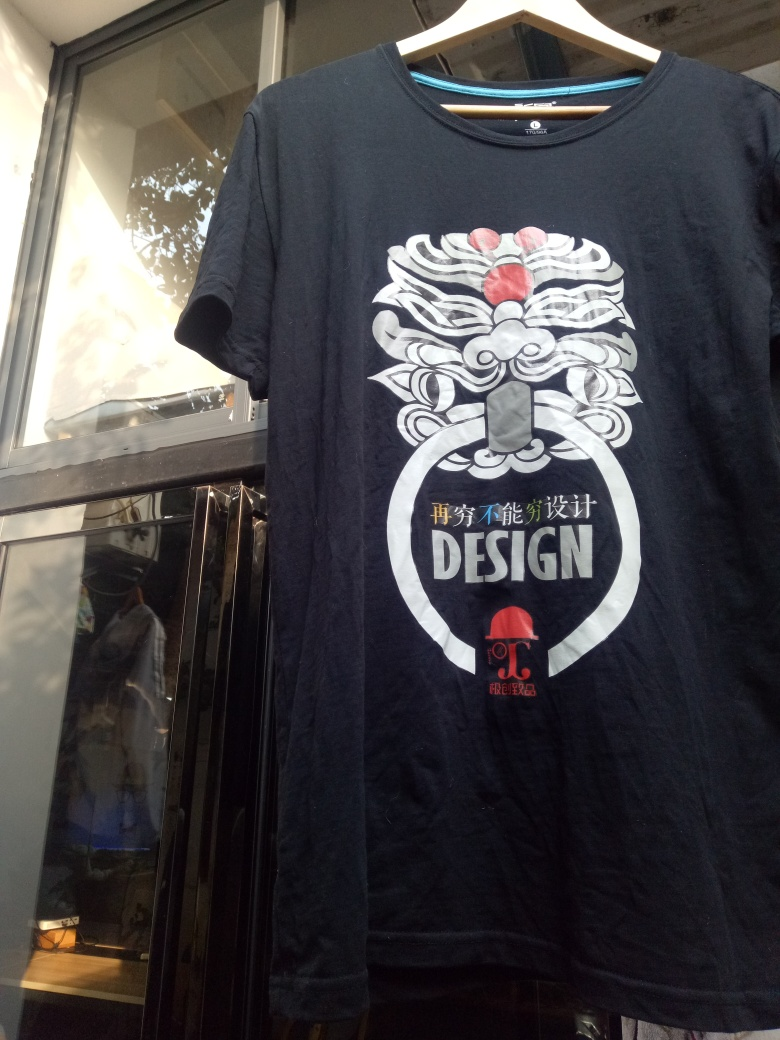Can you describe the surroundings in which the T-shirt is displayed? The T-shirt is displayed against a relatively dark backdrop, possibly inside a clothing store. There's a reflection visible in the glass pane covering the T-shirt, suggesting that it's hung behind a window. Due to the angle and lighting, further details about the surroundings are not clearly discernible, yet the environment implies an indoor setting with the T-shirt offered for sale or showcased. 